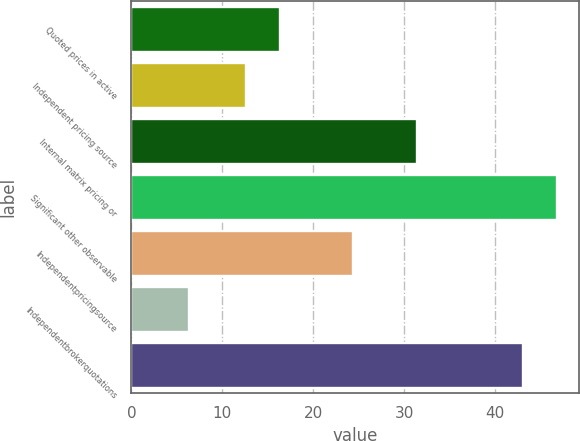Convert chart. <chart><loc_0><loc_0><loc_500><loc_500><bar_chart><fcel>Quoted prices in active<fcel>Independent pricing source<fcel>Internal matrix pricing or<fcel>Significant other observable<fcel>Independentpricingsource<fcel>Independentbrokerquotations<fcel>Unnamed: 6<nl><fcel>16.37<fcel>12.6<fcel>31.4<fcel>46.87<fcel>24.4<fcel>6.3<fcel>43.1<nl></chart> 